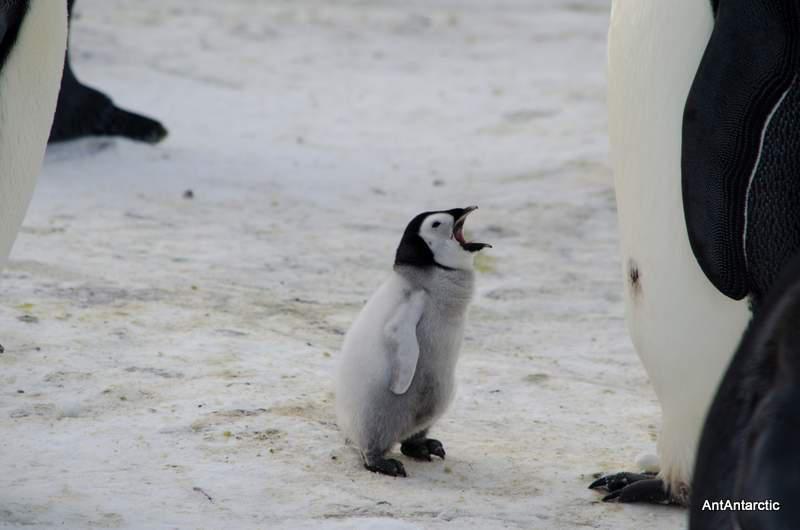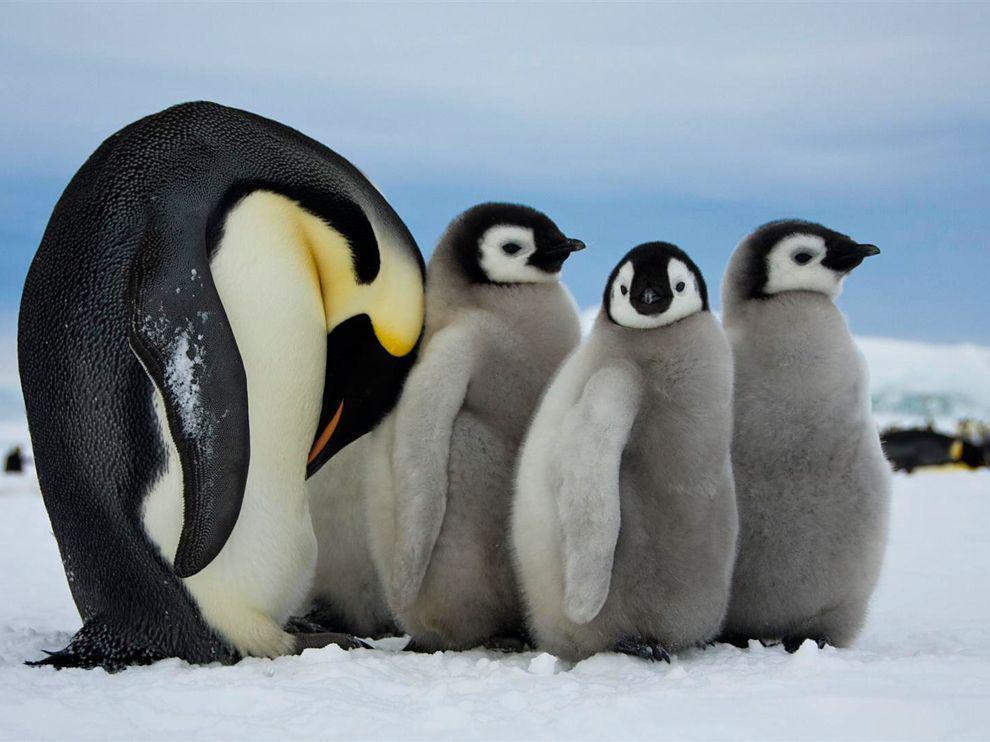The first image is the image on the left, the second image is the image on the right. Given the left and right images, does the statement "A baby penguin is standing near its mother with its mouth open." hold true? Answer yes or no. Yes. The first image is the image on the left, the second image is the image on the right. For the images displayed, is the sentence "In one image of each pait a baby penguin has its mouth wide open." factually correct? Answer yes or no. Yes. 